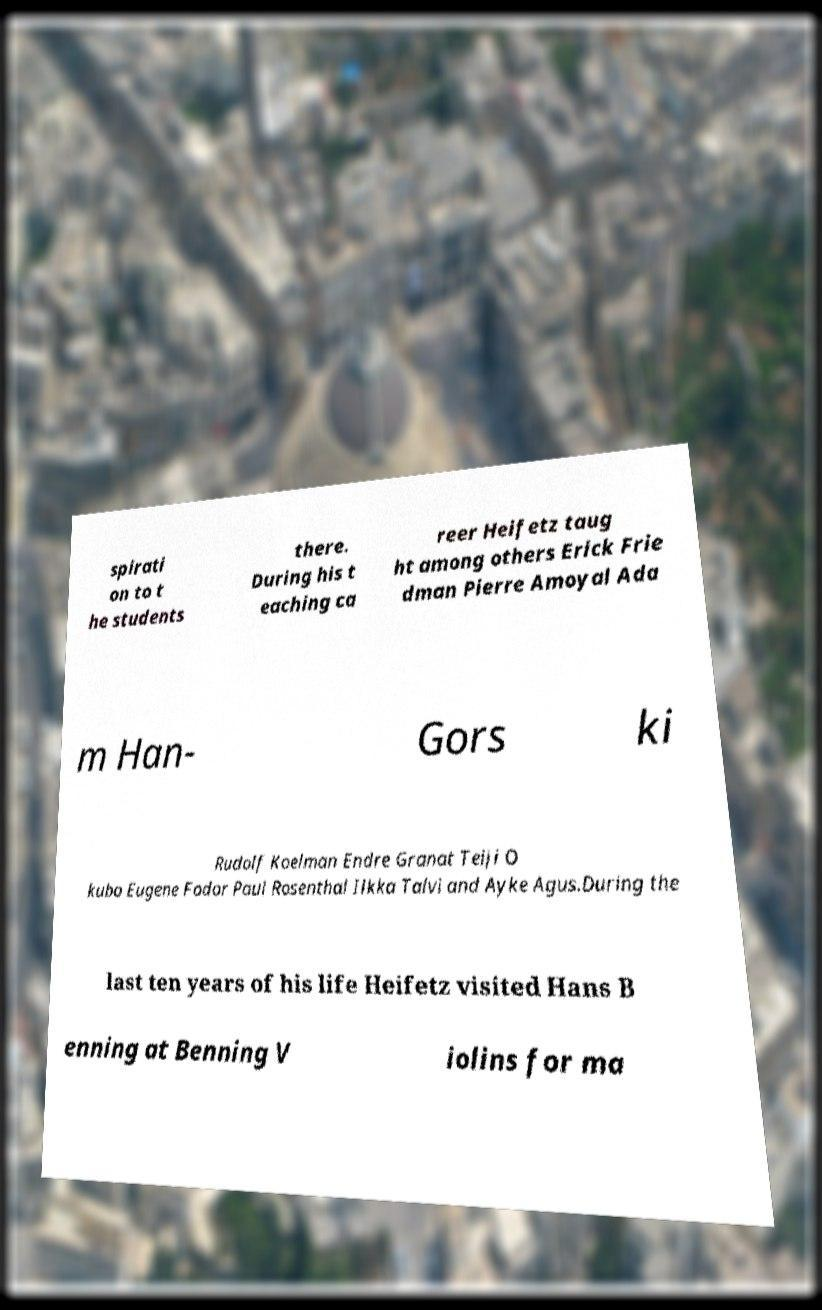Please identify and transcribe the text found in this image. spirati on to t he students there. During his t eaching ca reer Heifetz taug ht among others Erick Frie dman Pierre Amoyal Ada m Han- Gors ki Rudolf Koelman Endre Granat Teiji O kubo Eugene Fodor Paul Rosenthal Ilkka Talvi and Ayke Agus.During the last ten years of his life Heifetz visited Hans B enning at Benning V iolins for ma 